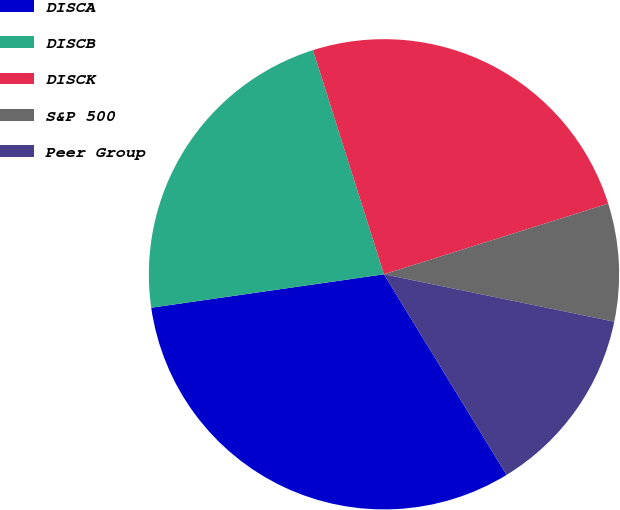Convert chart to OTSL. <chart><loc_0><loc_0><loc_500><loc_500><pie_chart><fcel>DISCA<fcel>DISCB<fcel>DISCK<fcel>S&P 500<fcel>Peer Group<nl><fcel>31.46%<fcel>22.39%<fcel>25.02%<fcel>8.09%<fcel>13.04%<nl></chart> 